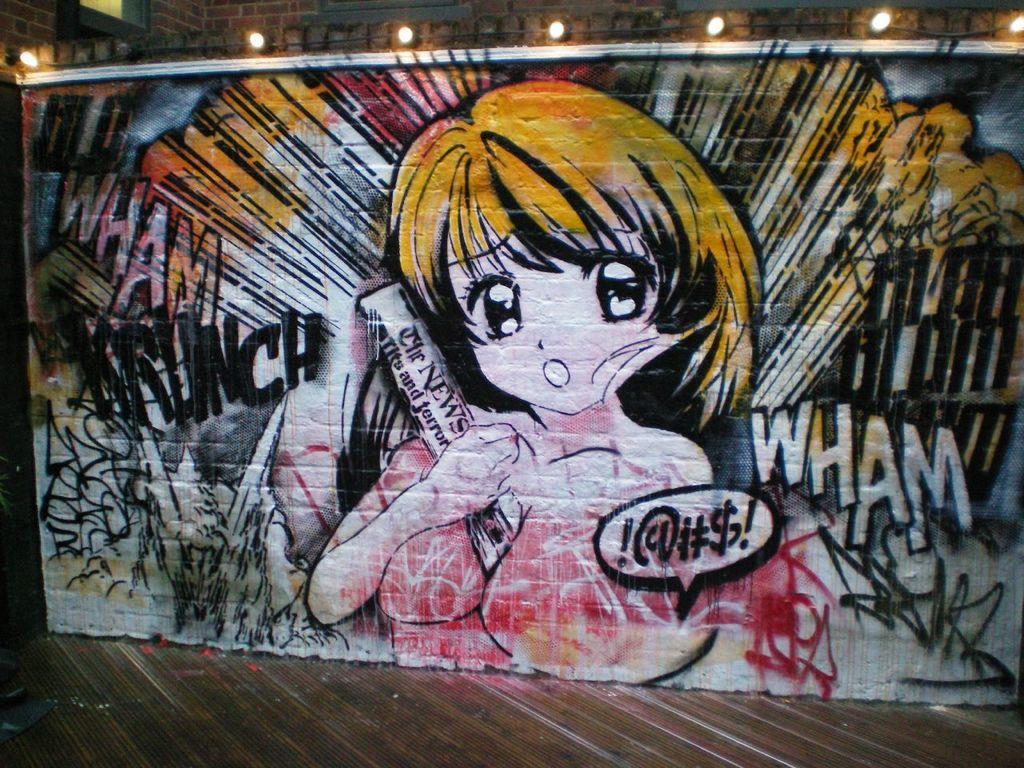Describe this image in one or two sentences. In this image we can see a picture of a cartoon painted on the wall. We can also see some lights and the floor. 